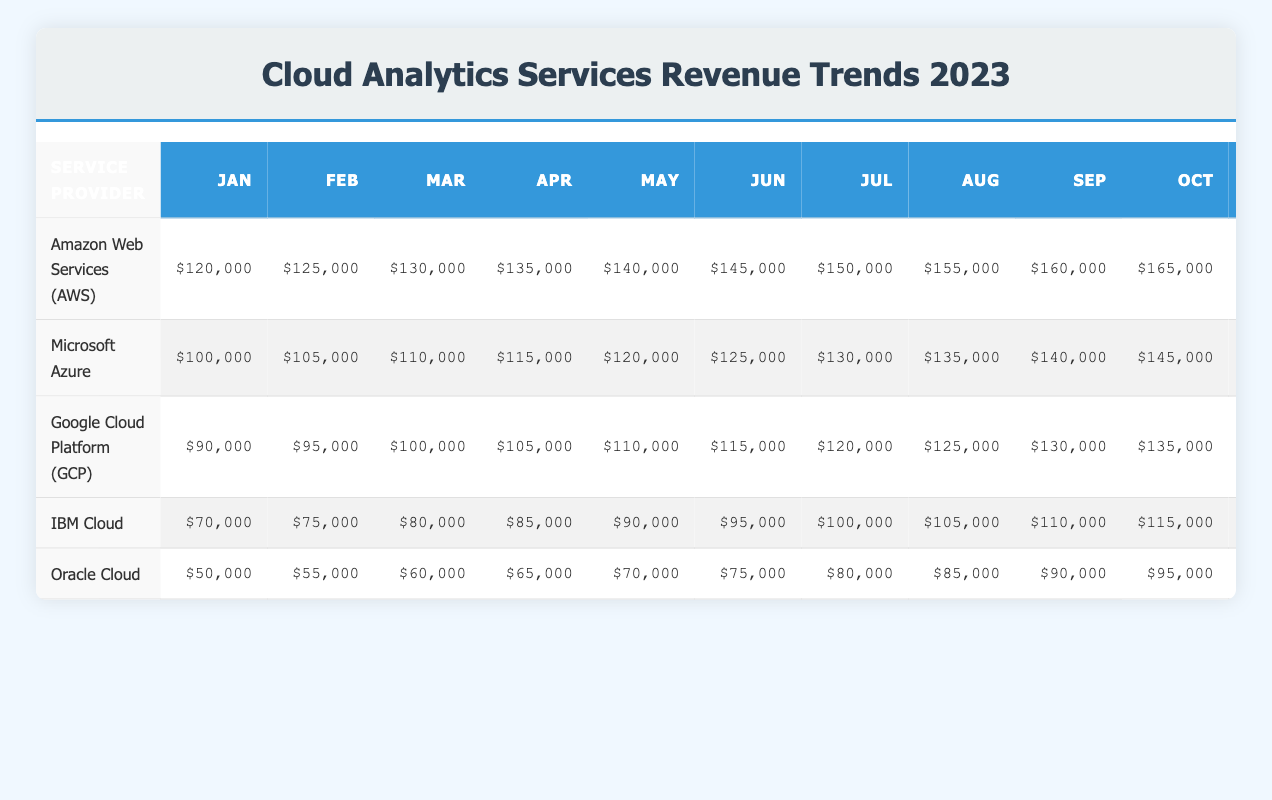What was the revenue of Google Cloud Platform (GCP) in June? The table shows that Google Cloud Platform (GCP) had a revenue of $115,000 in June.
Answer: $115,000 Which service provider had the highest revenue in December? By comparing the December revenues in the table, Amazon Web Services (AWS) had the highest revenue at $175,000.
Answer: Amazon Web Services (AWS) What is the total revenue for Oracle Cloud from January to March? To find the total revenue for Oracle Cloud from January to March, we add the values: $50,000 (January) + $55,000 (February) + $60,000 (March) = $165,000.
Answer: $165,000 Is the revenue of IBM Cloud higher in July than in January? Looking at the table, IBM Cloud's revenue in July is $100,000, while in January it is $70,000. Therefore, it is true that July's revenue is higher than January's.
Answer: Yes What is the average revenue for Microsoft Azure in the first half of the year (January to June)? The total revenue for Microsoft Azure from January to June is $100,000 + $105,000 + $110,000 + $115,000 + $120,000 + $125,000 = $675,000. There are 6 months, so the average revenue is $675,000 / 6 = $112,500.
Answer: $112,500 Which service provider showed the smallest increase in revenue from January to December? The increases for each provider from January to December are calculated: AWS ($175,000 - $120,000 = $55,000), Microsoft Azure ($155,000 - $100,000 = $55,000), GCP ($145,000 - $90,000 = $55,000), IBM Cloud ($125,000 - $70,000 = $55,000), and Oracle Cloud ($105,000 - $50,000 = $55,000). All providers show the same increase, hence no single provider has the smallest increase.
Answer: All have the same increase What was the total revenue for AWS for the first quarter of 2023? Adding up the revenues for the first three months for AWS gives: $120,000 (January) + $125,000 (February) + $130,000 (March) = $375,000.
Answer: $375,000 Was the revenue growth steady for all service providers throughout 2023? Reviewing the data, all service providers exhibit continuous growth month by month, suggesting that their revenue growth was steady throughout 2023.
Answer: Yes 